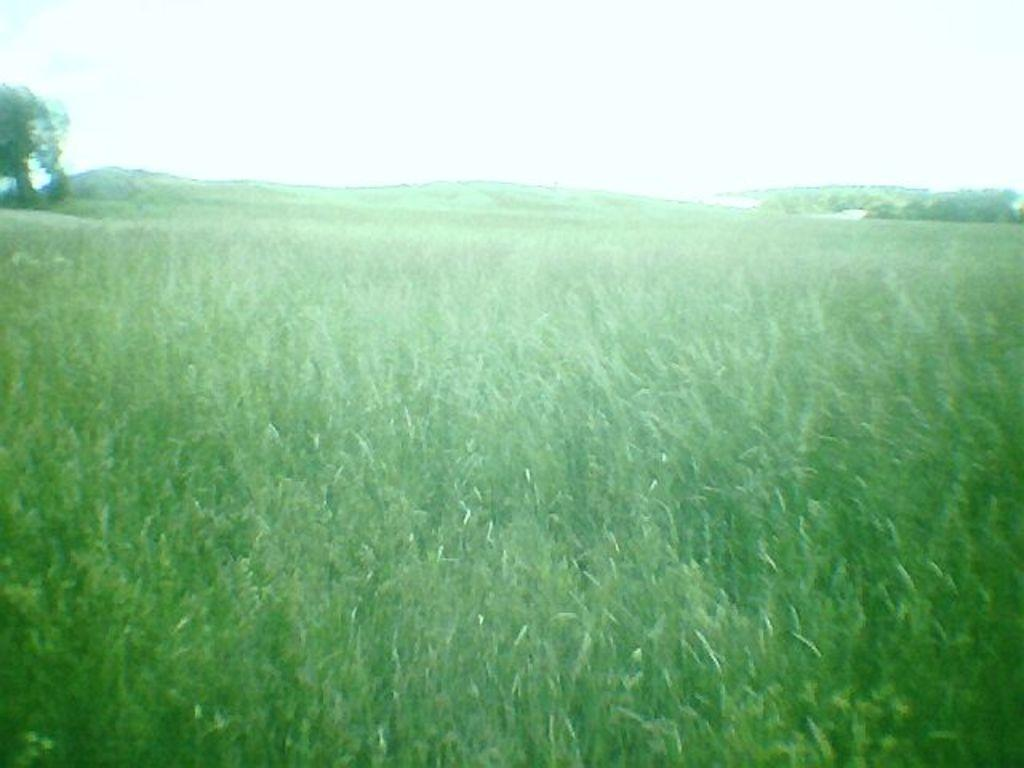What type of natural environment is depicted in the image? The image contains greenery, which suggests a natural environment. What specific plants can be seen in the image? There are crops and trees in the image. What can be seen in the background of the image? The sky is visible in the background of the image. What type of snow can be seen falling in the image? There is no snow present in the image; it depicts a natural environment with greenery, crops, trees, and a visible sky. 